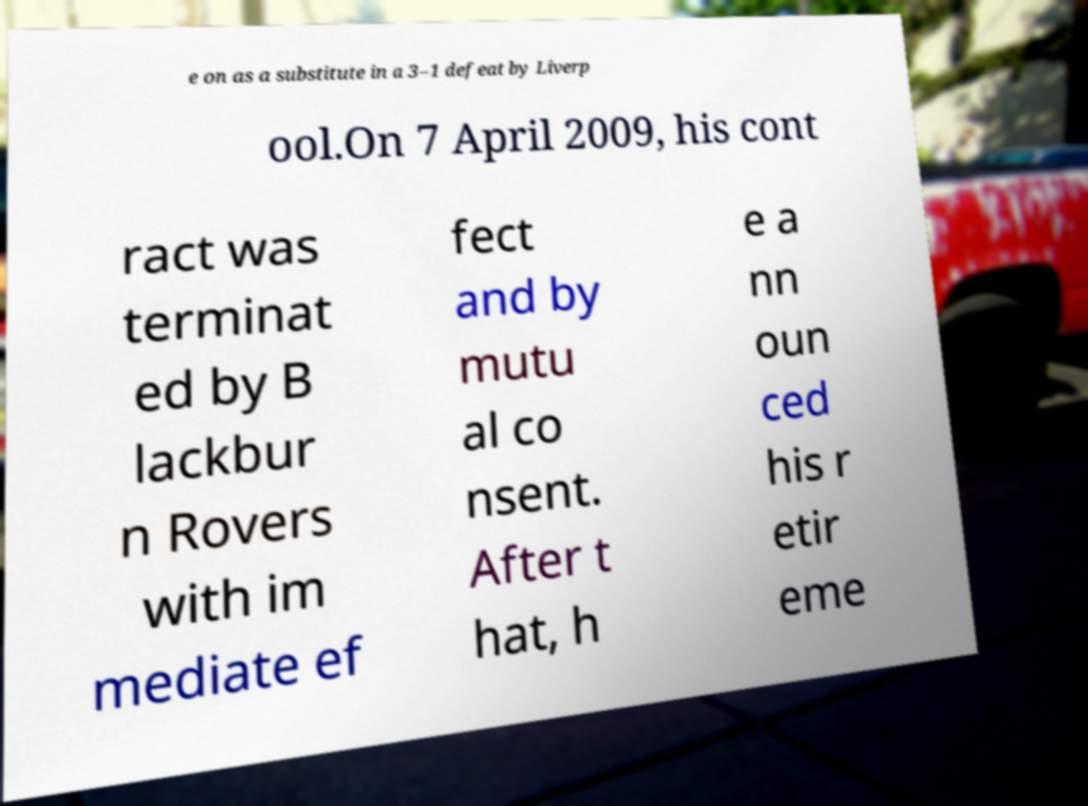There's text embedded in this image that I need extracted. Can you transcribe it verbatim? e on as a substitute in a 3–1 defeat by Liverp ool.On 7 April 2009, his cont ract was terminat ed by B lackbur n Rovers with im mediate ef fect and by mutu al co nsent. After t hat, h e a nn oun ced his r etir eme 